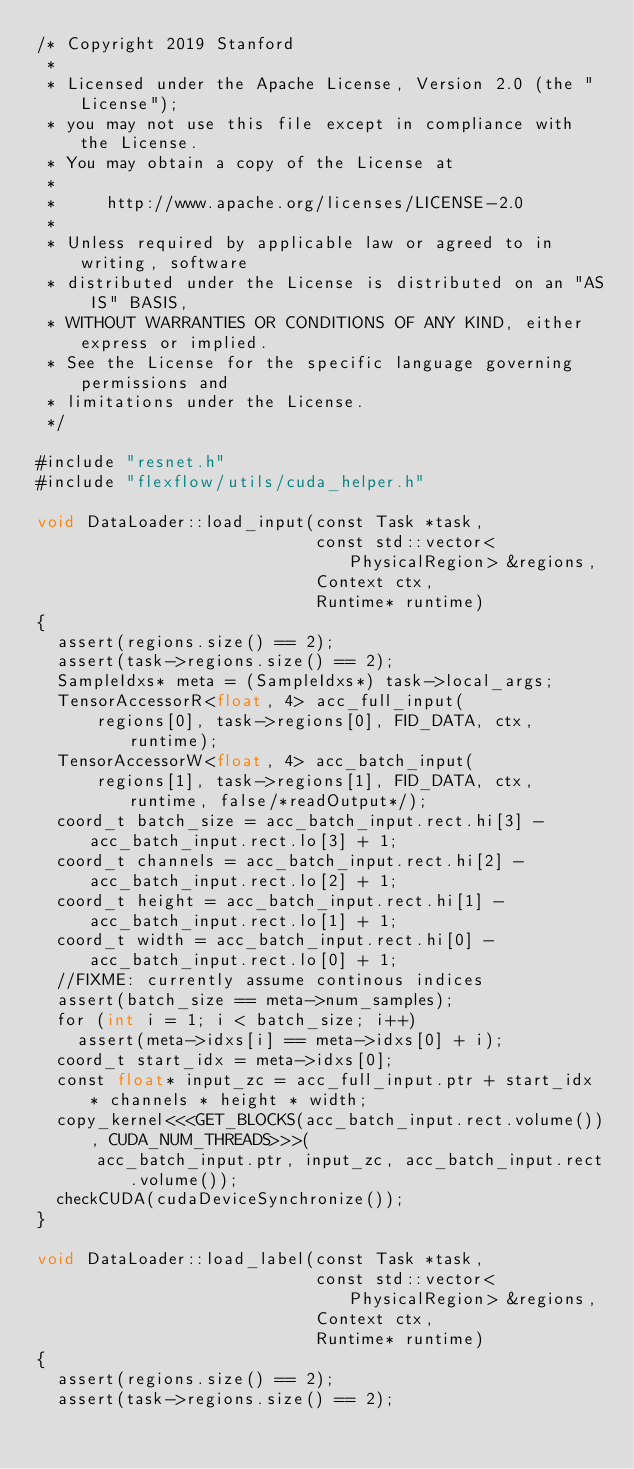Convert code to text. <code><loc_0><loc_0><loc_500><loc_500><_Cuda_>/* Copyright 2019 Stanford
 *
 * Licensed under the Apache License, Version 2.0 (the "License");
 * you may not use this file except in compliance with the License.
 * You may obtain a copy of the License at
 *
 *     http://www.apache.org/licenses/LICENSE-2.0
 *
 * Unless required by applicable law or agreed to in writing, software
 * distributed under the License is distributed on an "AS IS" BASIS,
 * WITHOUT WARRANTIES OR CONDITIONS OF ANY KIND, either express or implied.
 * See the License for the specific language governing permissions and
 * limitations under the License.
 */

#include "resnet.h"
#include "flexflow/utils/cuda_helper.h"

void DataLoader::load_input(const Task *task,
                            const std::vector<PhysicalRegion> &regions,
                            Context ctx,
                            Runtime* runtime)
{
  assert(regions.size() == 2);
  assert(task->regions.size() == 2);
  SampleIdxs* meta = (SampleIdxs*) task->local_args;
  TensorAccessorR<float, 4> acc_full_input(
      regions[0], task->regions[0], FID_DATA, ctx, runtime);
  TensorAccessorW<float, 4> acc_batch_input(
      regions[1], task->regions[1], FID_DATA, ctx, runtime, false/*readOutput*/);
  coord_t batch_size = acc_batch_input.rect.hi[3] - acc_batch_input.rect.lo[3] + 1;
  coord_t channels = acc_batch_input.rect.hi[2] - acc_batch_input.rect.lo[2] + 1;
  coord_t height = acc_batch_input.rect.hi[1] - acc_batch_input.rect.lo[1] + 1;
  coord_t width = acc_batch_input.rect.hi[0] - acc_batch_input.rect.lo[0] + 1;
  //FIXME: currently assume continous indices
  assert(batch_size == meta->num_samples);
  for (int i = 1; i < batch_size; i++)
    assert(meta->idxs[i] == meta->idxs[0] + i);
  coord_t start_idx = meta->idxs[0];
  const float* input_zc = acc_full_input.ptr + start_idx * channels * height * width;
  copy_kernel<<<GET_BLOCKS(acc_batch_input.rect.volume()), CUDA_NUM_THREADS>>>(
      acc_batch_input.ptr, input_zc, acc_batch_input.rect.volume());
  checkCUDA(cudaDeviceSynchronize());
}

void DataLoader::load_label(const Task *task,
                            const std::vector<PhysicalRegion> &regions,
                            Context ctx,
                            Runtime* runtime)
{
  assert(regions.size() == 2);
  assert(task->regions.size() == 2);</code> 